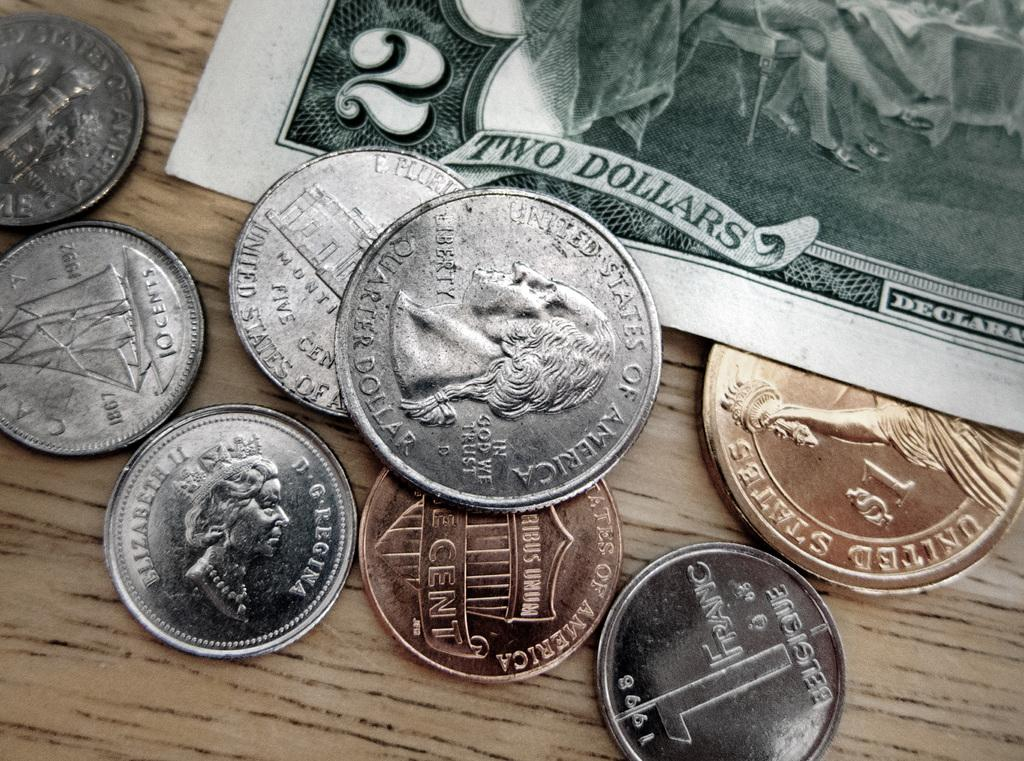<image>
Relay a brief, clear account of the picture shown. The two dollar bill is green and crisp in lettering amongst the In God We Trust slogan on the quarter. 